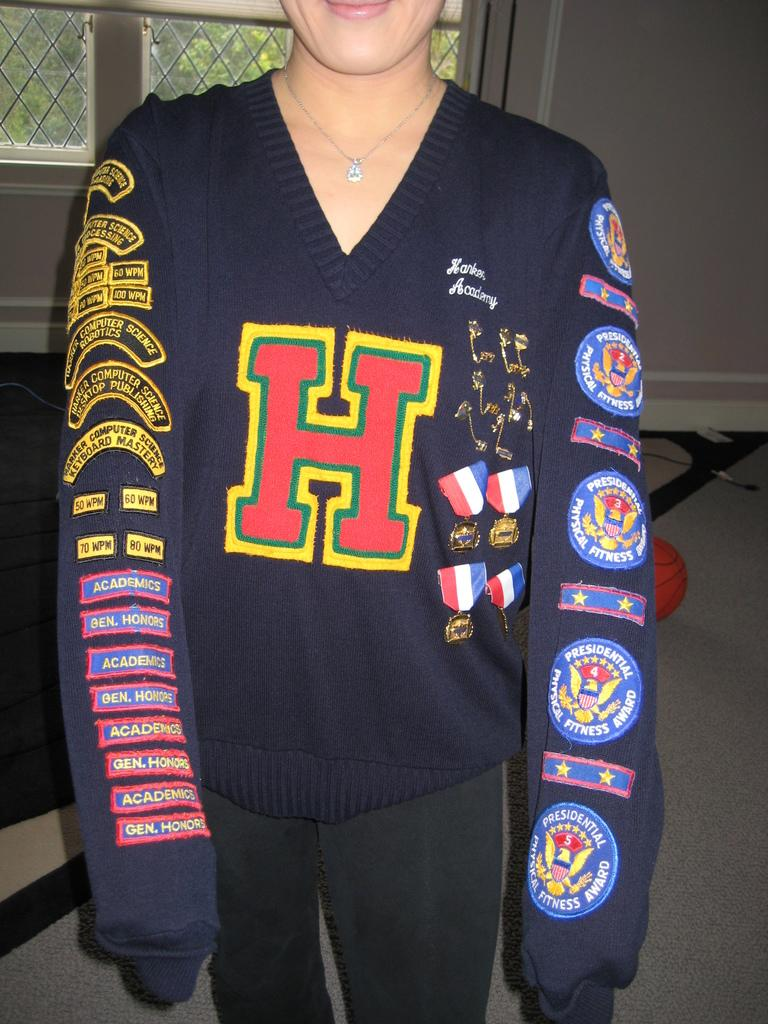<image>
Offer a succinct explanation of the picture presented. A person wearing a shirt with patches on it one of them being a PRESIDENTIAL PHYSICAL FITNESS AWARD. 